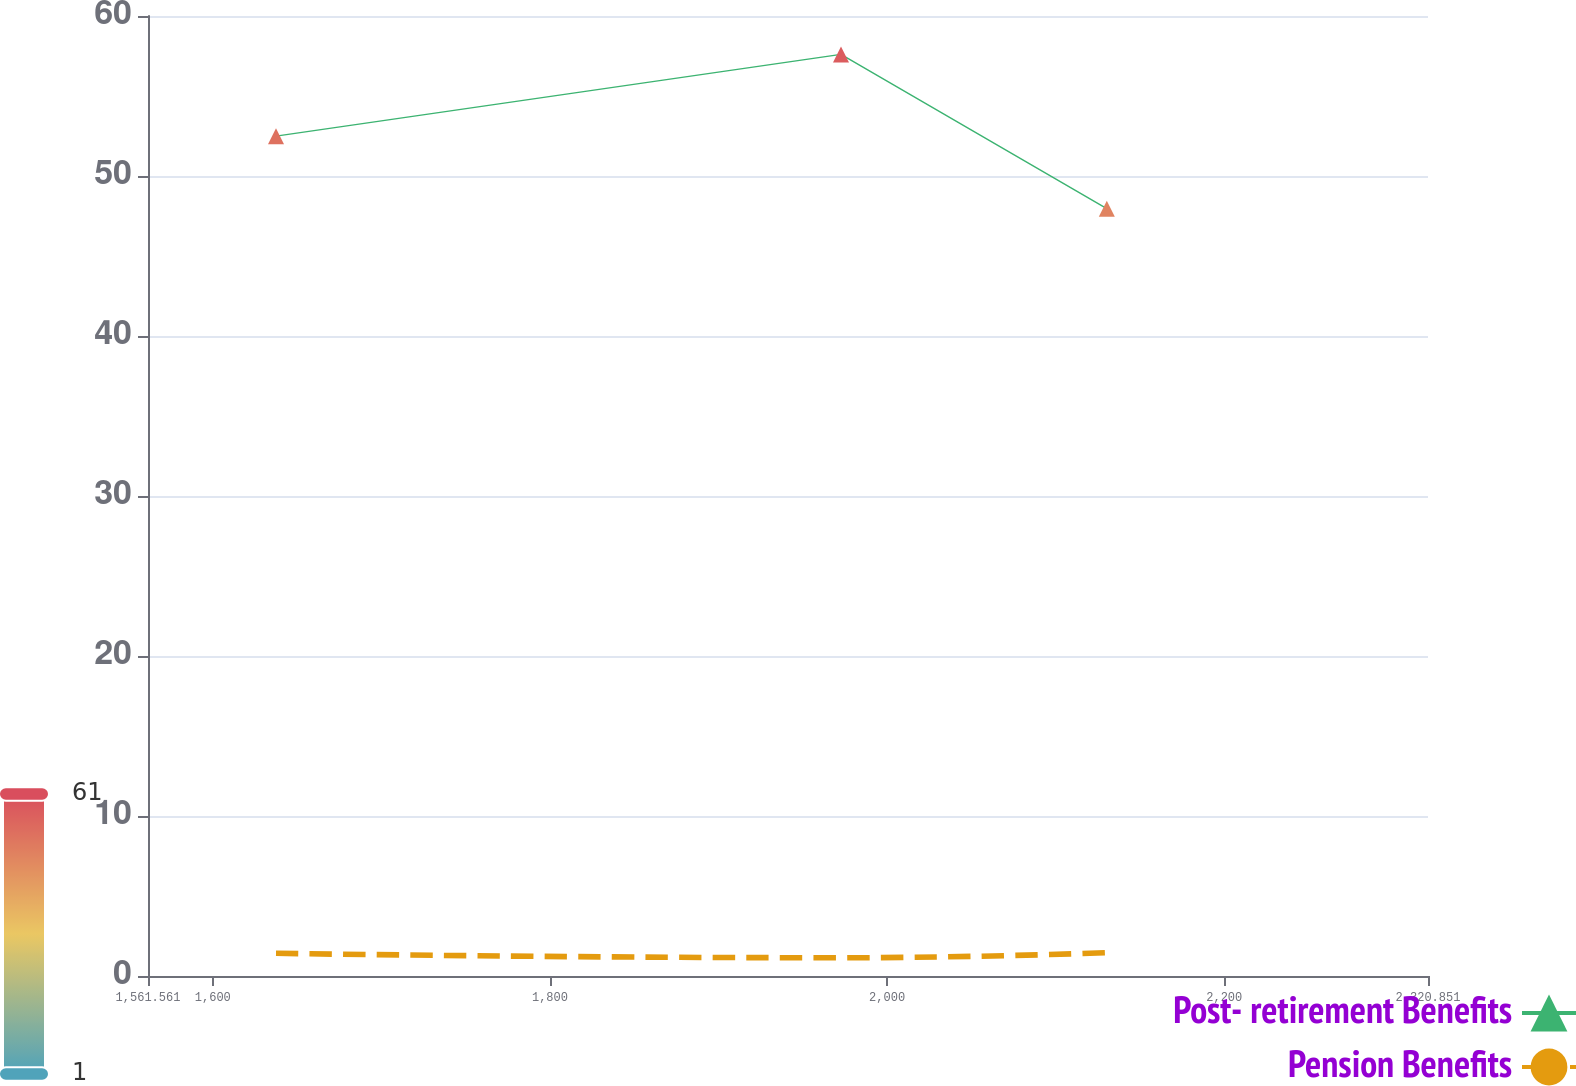Convert chart to OTSL. <chart><loc_0><loc_0><loc_500><loc_500><line_chart><ecel><fcel>Post- retirement Benefits<fcel>Pension Benefits<nl><fcel>1637.49<fcel>52.49<fcel>1.42<nl><fcel>1972.63<fcel>57.6<fcel>1.14<nl><fcel>2130.32<fcel>47.96<fcel>1.46<nl><fcel>2321.85<fcel>61.09<fcel>1.39<nl><fcel>2396.78<fcel>56.29<fcel>1.31<nl></chart> 